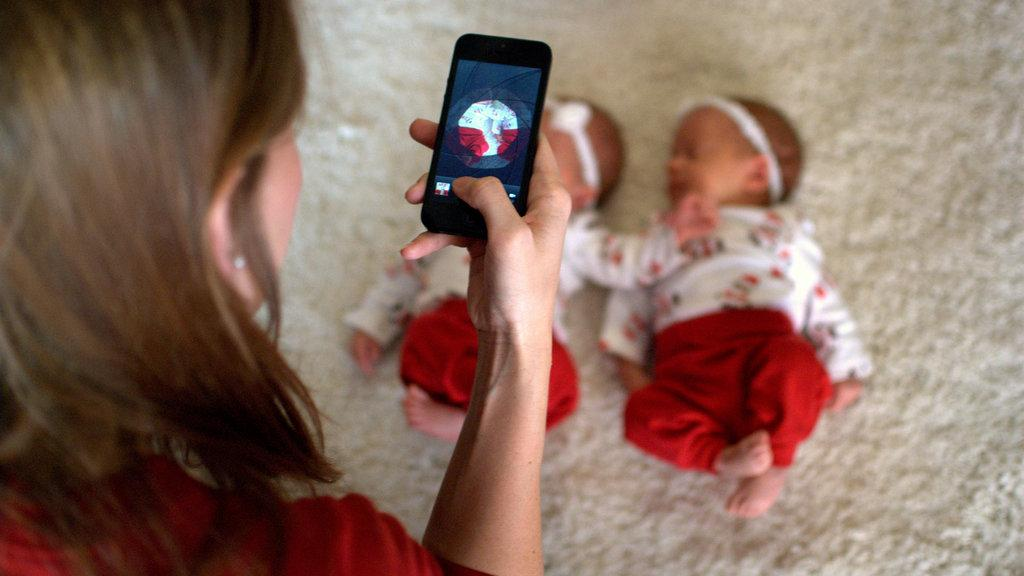Who is present in the image? There is a woman in the image. What is the woman holding in her hand? The woman is holding a phone in her hand. What else can be seen in the image besides the woman? There are two babies visible in the image. How are the babies positioned in the image? The babies are lying on a white cloth. Are there any boys visible in the image? The provided facts do not mention any boys in the image, only two babies. It is not specified whether they are boys or girls. 